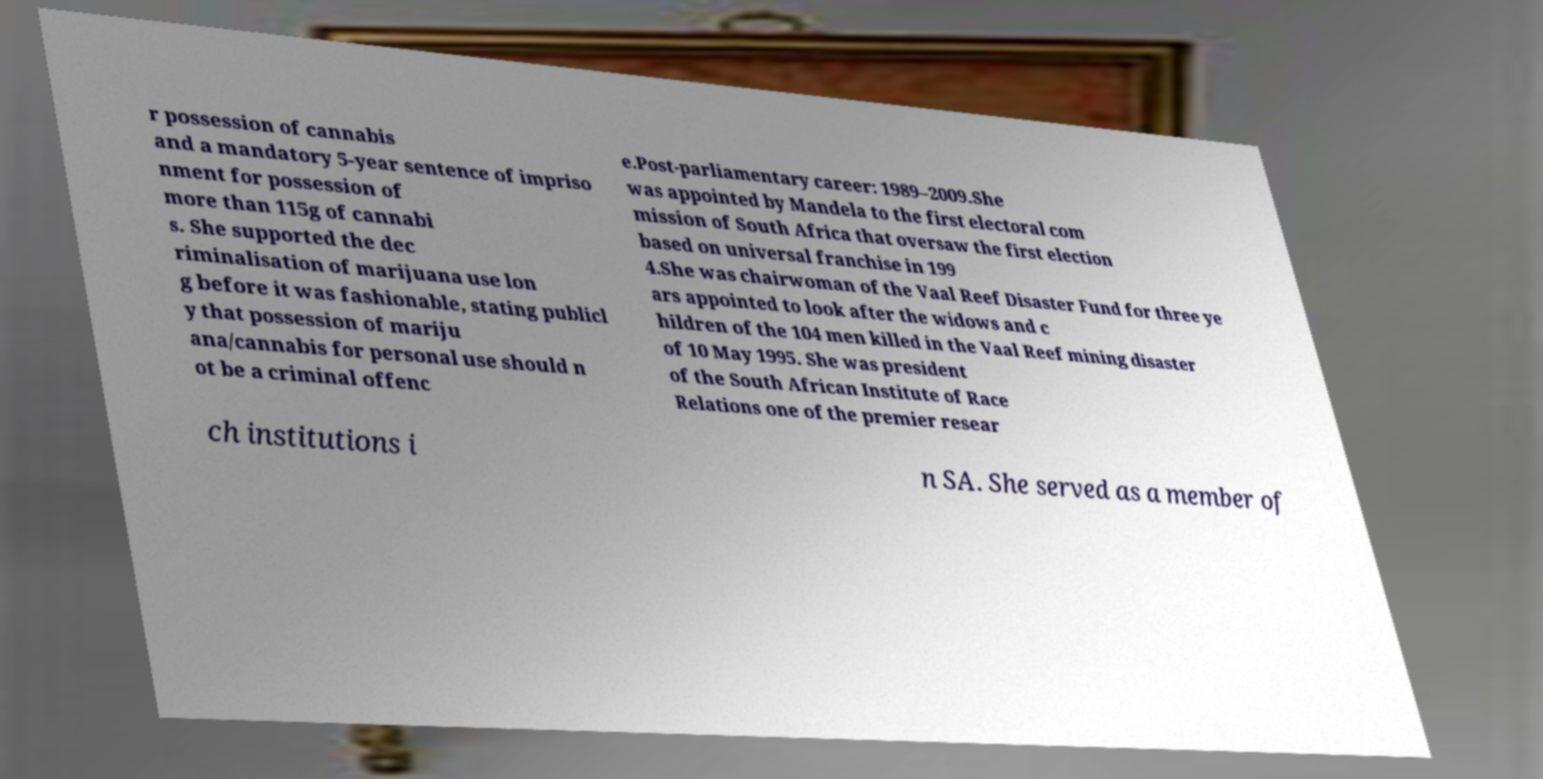Can you accurately transcribe the text from the provided image for me? r possession of cannabis and a mandatory 5-year sentence of impriso nment for possession of more than 115g of cannabi s. She supported the dec riminalisation of marijuana use lon g before it was fashionable, stating publicl y that possession of mariju ana/cannabis for personal use should n ot be a criminal offenc e.Post-parliamentary career: 1989–2009.She was appointed by Mandela to the first electoral com mission of South Africa that oversaw the first election based on universal franchise in 199 4.She was chairwoman of the Vaal Reef Disaster Fund for three ye ars appointed to look after the widows and c hildren of the 104 men killed in the Vaal Reef mining disaster of 10 May 1995. She was president of the South African Institute of Race Relations one of the premier resear ch institutions i n SA. She served as a member of 